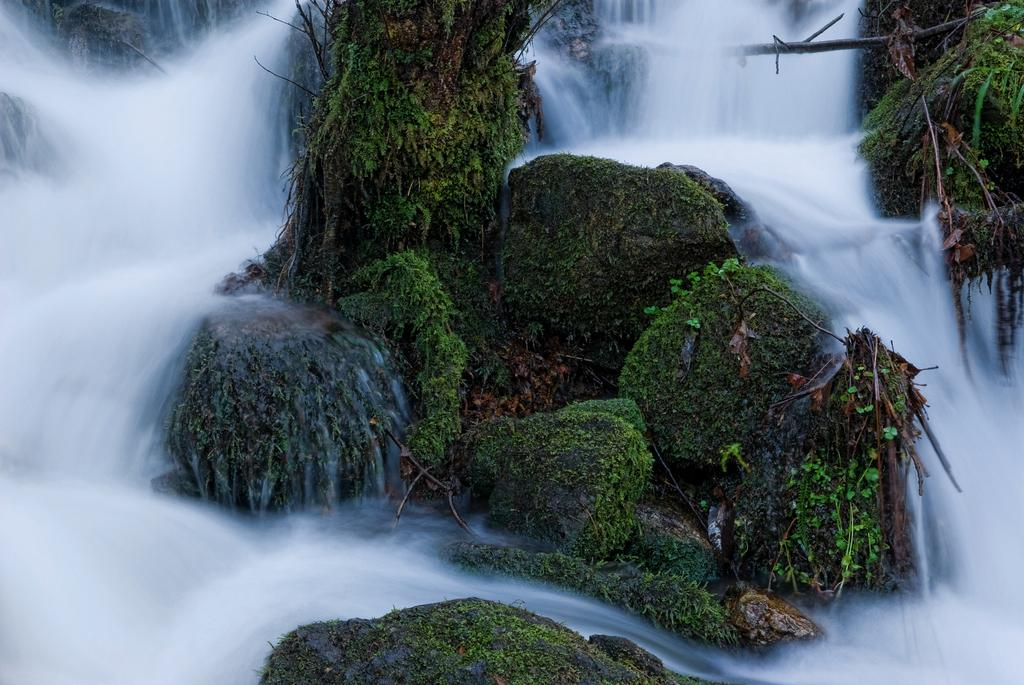What is happening in the image? Water is flowing in the image. What can be seen in the water? Rock stones are present in the image. How are the rock stones different from typical rocks? The rock stones are covered with plants. What else can be observed on the rock stones? Algae are present on the rock stones. What type of writing can be seen on the rock stones in the image? There is no writing present on the rock stones in the image. Is there a bear visible in the image? There is no bear present in the image. 